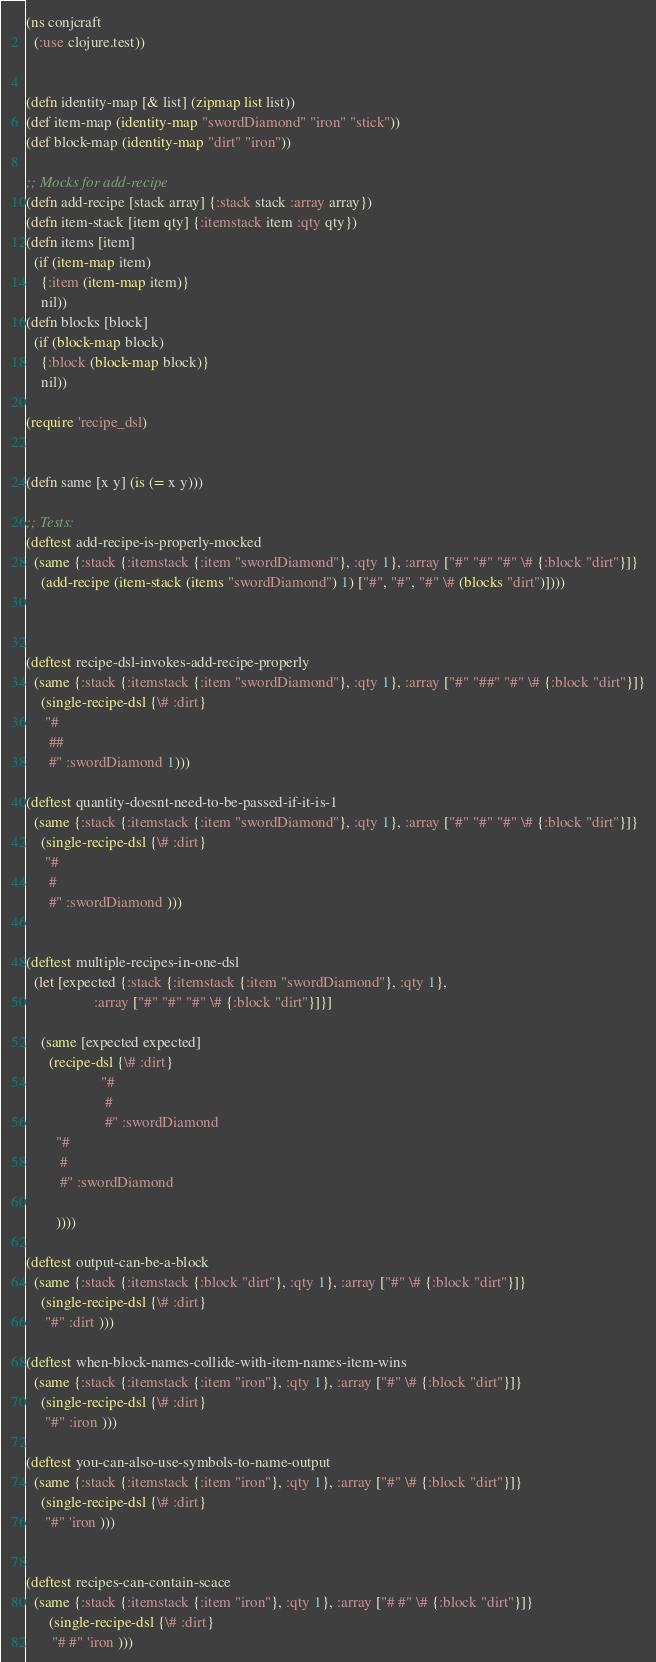Convert code to text. <code><loc_0><loc_0><loc_500><loc_500><_Clojure_>(ns conjcraft
  (:use clojure.test))


(defn identity-map [& list] (zipmap list list))
(def item-map (identity-map "swordDiamond" "iron" "stick"))
(def block-map (identity-map "dirt" "iron"))

;; Mocks for add-recipe
(defn add-recipe [stack array] {:stack stack :array array})
(defn item-stack [item qty] {:itemstack item :qty qty})
(defn items [item]
  (if (item-map item)
    {:item (item-map item)}
    nil))
(defn blocks [block]
  (if (block-map block)
    {:block (block-map block)}
    nil))

(require 'recipe_dsl)


(defn same [x y] (is (= x y)))

;; Tests:
(deftest add-recipe-is-properly-mocked
  (same {:stack {:itemstack {:item "swordDiamond"}, :qty 1}, :array ["#" "#" "#" \# {:block "dirt"}]}
    (add-recipe (item-stack (items "swordDiamond") 1) ["#", "#", "#" \# (blocks "dirt")])))



(deftest recipe-dsl-invokes-add-recipe-properly
  (same {:stack {:itemstack {:item "swordDiamond"}, :qty 1}, :array ["#" "##" "#" \# {:block "dirt"}]}
    (single-recipe-dsl {\# :dirt}
     "#
      ##
      #" :swordDiamond 1)))

(deftest quantity-doesnt-need-to-be-passed-if-it-is-1
  (same {:stack {:itemstack {:item "swordDiamond"}, :qty 1}, :array ["#" "#" "#" \# {:block "dirt"}]}
    (single-recipe-dsl {\# :dirt}
     "#
      #
      #" :swordDiamond )))


(deftest multiple-recipes-in-one-dsl
  (let [expected {:stack {:itemstack {:item "swordDiamond"}, :qty 1},
                  :array ["#" "#" "#" \# {:block "dirt"}]}]

    (same [expected expected]
      (recipe-dsl {\# :dirt}
                    "#
                     #
                     #" :swordDiamond
        "#
         #
         #" :swordDiamond

        ))))

(deftest output-can-be-a-block
  (same {:stack {:itemstack {:block "dirt"}, :qty 1}, :array ["#" \# {:block "dirt"}]}
    (single-recipe-dsl {\# :dirt}
     "#" :dirt )))

(deftest when-block-names-collide-with-item-names-item-wins
  (same {:stack {:itemstack {:item "iron"}, :qty 1}, :array ["#" \# {:block "dirt"}]}
    (single-recipe-dsl {\# :dirt}
     "#" :iron )))

(deftest you-can-also-use-symbols-to-name-output
  (same {:stack {:itemstack {:item "iron"}, :qty 1}, :array ["#" \# {:block "dirt"}]}
    (single-recipe-dsl {\# :dirt}
     "#" 'iron )))


(deftest recipes-can-contain-scace
  (same {:stack {:itemstack {:item "iron"}, :qty 1}, :array ["# #" \# {:block "dirt"}]}
      (single-recipe-dsl {\# :dirt}
       "# #" 'iron )))
</code> 